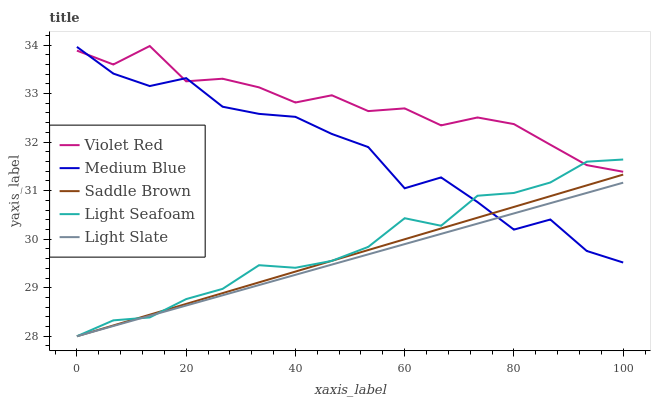Does Light Slate have the minimum area under the curve?
Answer yes or no. Yes. Does Violet Red have the maximum area under the curve?
Answer yes or no. Yes. Does Light Seafoam have the minimum area under the curve?
Answer yes or no. No. Does Light Seafoam have the maximum area under the curve?
Answer yes or no. No. Is Light Slate the smoothest?
Answer yes or no. Yes. Is Medium Blue the roughest?
Answer yes or no. Yes. Is Violet Red the smoothest?
Answer yes or no. No. Is Violet Red the roughest?
Answer yes or no. No. Does Light Slate have the lowest value?
Answer yes or no. Yes. Does Violet Red have the lowest value?
Answer yes or no. No. Does Violet Red have the highest value?
Answer yes or no. Yes. Does Light Seafoam have the highest value?
Answer yes or no. No. Is Light Slate less than Violet Red?
Answer yes or no. Yes. Is Violet Red greater than Saddle Brown?
Answer yes or no. Yes. Does Saddle Brown intersect Light Seafoam?
Answer yes or no. Yes. Is Saddle Brown less than Light Seafoam?
Answer yes or no. No. Is Saddle Brown greater than Light Seafoam?
Answer yes or no. No. Does Light Slate intersect Violet Red?
Answer yes or no. No. 